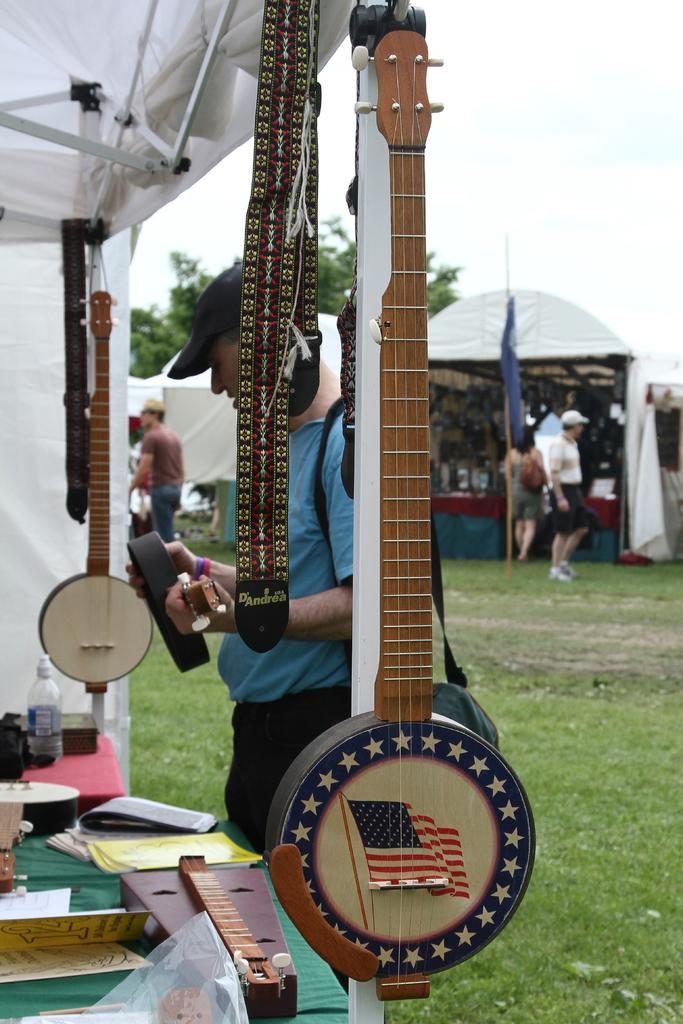What type of structures are visible in the image? There are stalls in the image. What can be found in at least one of the stalls? At least one stall contains musical instruments. Can you describe the people in the image? There are persons standing in the background of the image. What can be seen in the distance behind the stalls and people? Trees and the sky are visible in the background of the image. What type of cat can be seen climbing a cherry tree in the image? There is no cat or cherry tree present in the image. How many times do the persons in the image sneeze? There is no indication of anyone sneezing in the image. 